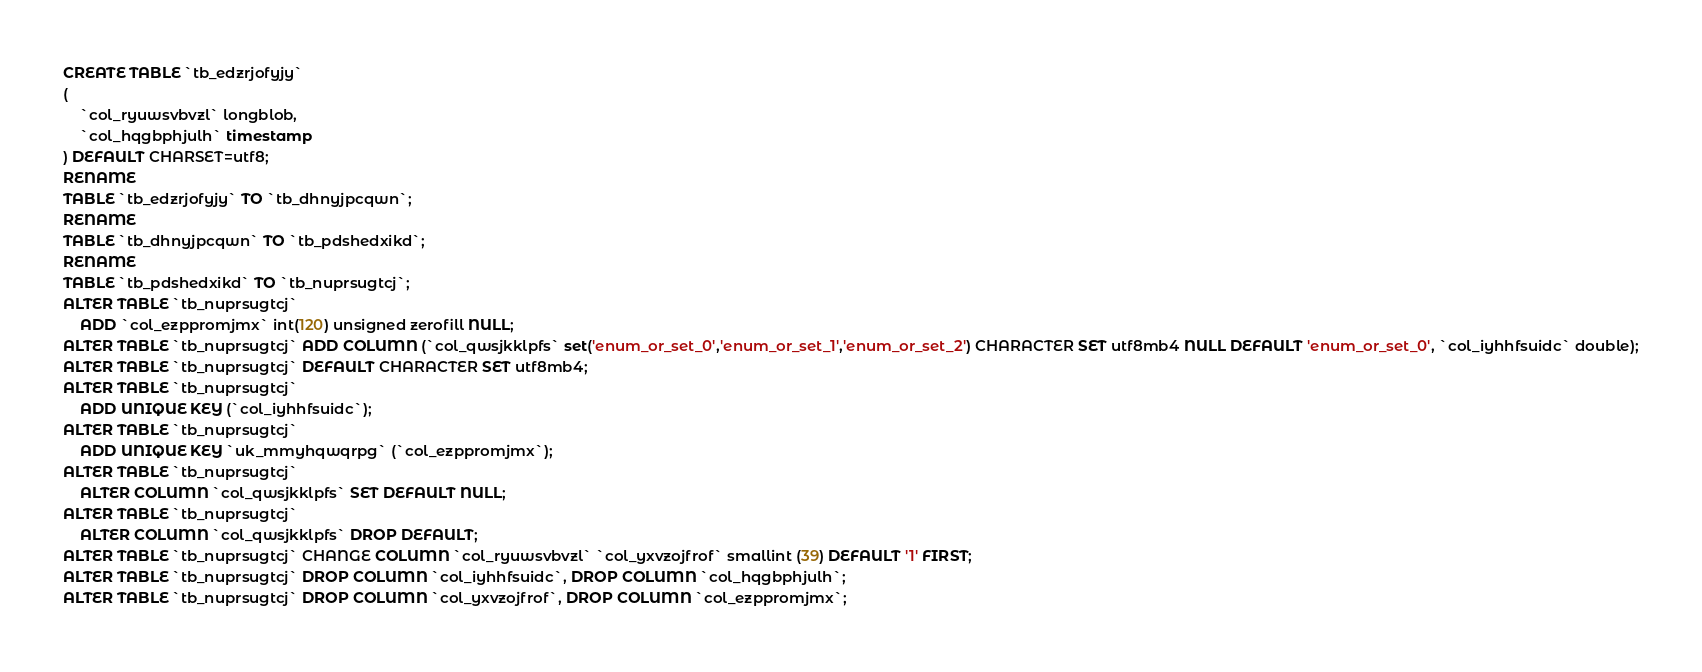Convert code to text. <code><loc_0><loc_0><loc_500><loc_500><_SQL_>CREATE TABLE `tb_edzrjofyjy`
(
    `col_ryuwsvbvzl` longblob,
    `col_hqgbphjulh` timestamp
) DEFAULT CHARSET=utf8;
RENAME
TABLE `tb_edzrjofyjy` TO `tb_dhnyjpcqwn`;
RENAME
TABLE `tb_dhnyjpcqwn` TO `tb_pdshedxikd`;
RENAME
TABLE `tb_pdshedxikd` TO `tb_nuprsugtcj`;
ALTER TABLE `tb_nuprsugtcj`
    ADD `col_ezppromjmx` int(120) unsigned zerofill NULL;
ALTER TABLE `tb_nuprsugtcj` ADD COLUMN (`col_qwsjkklpfs` set('enum_or_set_0','enum_or_set_1','enum_or_set_2') CHARACTER SET utf8mb4 NULL DEFAULT 'enum_or_set_0', `col_iyhhfsuidc` double);
ALTER TABLE `tb_nuprsugtcj` DEFAULT CHARACTER SET utf8mb4;
ALTER TABLE `tb_nuprsugtcj`
    ADD UNIQUE KEY (`col_iyhhfsuidc`);
ALTER TABLE `tb_nuprsugtcj`
    ADD UNIQUE KEY `uk_mmyhqwqrpg` (`col_ezppromjmx`);
ALTER TABLE `tb_nuprsugtcj`
    ALTER COLUMN `col_qwsjkklpfs` SET DEFAULT NULL;
ALTER TABLE `tb_nuprsugtcj`
    ALTER COLUMN `col_qwsjkklpfs` DROP DEFAULT;
ALTER TABLE `tb_nuprsugtcj` CHANGE COLUMN `col_ryuwsvbvzl` `col_yxvzojfrof` smallint (39) DEFAULT '1' FIRST;
ALTER TABLE `tb_nuprsugtcj` DROP COLUMN `col_iyhhfsuidc`, DROP COLUMN `col_hqgbphjulh`;
ALTER TABLE `tb_nuprsugtcj` DROP COLUMN `col_yxvzojfrof`, DROP COLUMN `col_ezppromjmx`;
</code> 